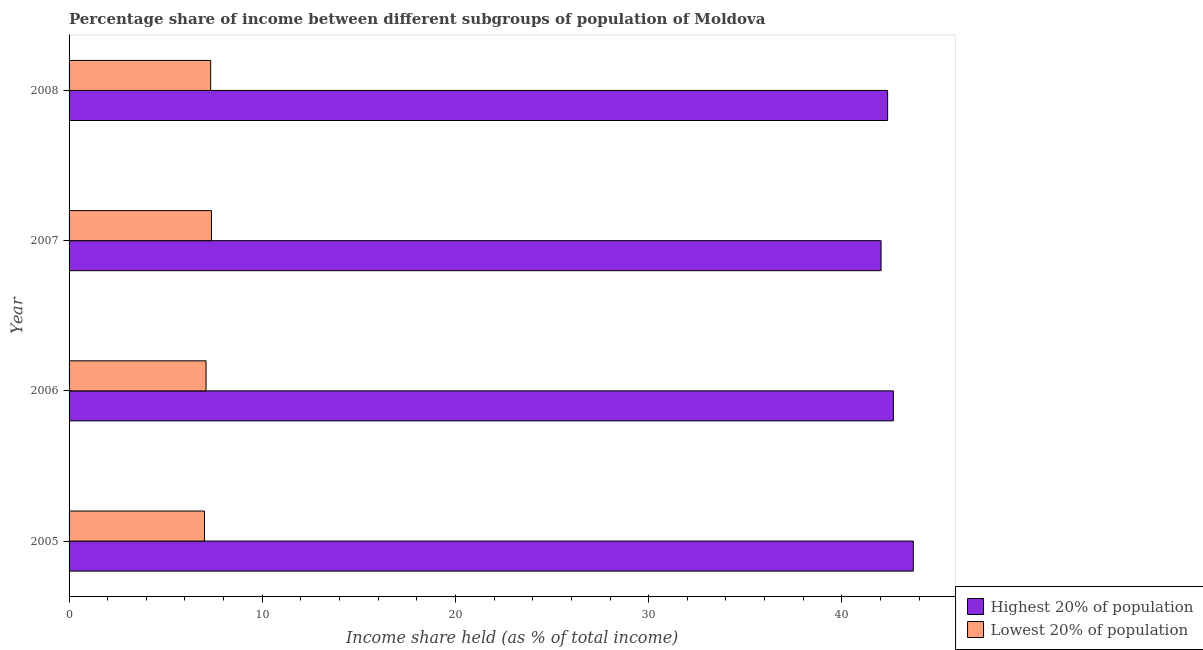How many different coloured bars are there?
Make the answer very short. 2. How many groups of bars are there?
Your response must be concise. 4. Are the number of bars per tick equal to the number of legend labels?
Keep it short and to the point. Yes. How many bars are there on the 1st tick from the bottom?
Offer a terse response. 2. What is the label of the 3rd group of bars from the top?
Your answer should be very brief. 2006. In how many cases, is the number of bars for a given year not equal to the number of legend labels?
Make the answer very short. 0. What is the income share held by lowest 20% of the population in 2006?
Your answer should be compact. 7.09. Across all years, what is the maximum income share held by lowest 20% of the population?
Your response must be concise. 7.37. Across all years, what is the minimum income share held by highest 20% of the population?
Keep it short and to the point. 42.03. In which year was the income share held by highest 20% of the population maximum?
Keep it short and to the point. 2005. What is the total income share held by lowest 20% of the population in the graph?
Your answer should be very brief. 28.8. What is the difference between the income share held by highest 20% of the population in 2007 and that in 2008?
Ensure brevity in your answer.  -0.34. What is the difference between the income share held by lowest 20% of the population in 2005 and the income share held by highest 20% of the population in 2008?
Offer a very short reply. -35.36. What is the average income share held by lowest 20% of the population per year?
Provide a short and direct response. 7.2. In the year 2006, what is the difference between the income share held by highest 20% of the population and income share held by lowest 20% of the population?
Give a very brief answer. 35.58. What is the ratio of the income share held by lowest 20% of the population in 2007 to that in 2008?
Make the answer very short. 1. Is the difference between the income share held by lowest 20% of the population in 2005 and 2006 greater than the difference between the income share held by highest 20% of the population in 2005 and 2006?
Keep it short and to the point. No. What is the difference between the highest and the lowest income share held by highest 20% of the population?
Provide a succinct answer. 1.67. In how many years, is the income share held by highest 20% of the population greater than the average income share held by highest 20% of the population taken over all years?
Offer a very short reply. 1. What does the 2nd bar from the top in 2006 represents?
Give a very brief answer. Highest 20% of population. What does the 2nd bar from the bottom in 2007 represents?
Offer a very short reply. Lowest 20% of population. Are all the bars in the graph horizontal?
Make the answer very short. Yes. Are the values on the major ticks of X-axis written in scientific E-notation?
Offer a very short reply. No. Does the graph contain grids?
Keep it short and to the point. No. How are the legend labels stacked?
Offer a very short reply. Vertical. What is the title of the graph?
Keep it short and to the point. Percentage share of income between different subgroups of population of Moldova. What is the label or title of the X-axis?
Provide a succinct answer. Income share held (as % of total income). What is the Income share held (as % of total income) of Highest 20% of population in 2005?
Your answer should be very brief. 43.7. What is the Income share held (as % of total income) of Lowest 20% of population in 2005?
Your answer should be very brief. 7.01. What is the Income share held (as % of total income) in Highest 20% of population in 2006?
Ensure brevity in your answer.  42.67. What is the Income share held (as % of total income) in Lowest 20% of population in 2006?
Your answer should be very brief. 7.09. What is the Income share held (as % of total income) of Highest 20% of population in 2007?
Your response must be concise. 42.03. What is the Income share held (as % of total income) of Lowest 20% of population in 2007?
Provide a short and direct response. 7.37. What is the Income share held (as % of total income) in Highest 20% of population in 2008?
Keep it short and to the point. 42.37. What is the Income share held (as % of total income) in Lowest 20% of population in 2008?
Ensure brevity in your answer.  7.33. Across all years, what is the maximum Income share held (as % of total income) of Highest 20% of population?
Give a very brief answer. 43.7. Across all years, what is the maximum Income share held (as % of total income) of Lowest 20% of population?
Keep it short and to the point. 7.37. Across all years, what is the minimum Income share held (as % of total income) of Highest 20% of population?
Make the answer very short. 42.03. Across all years, what is the minimum Income share held (as % of total income) in Lowest 20% of population?
Your answer should be compact. 7.01. What is the total Income share held (as % of total income) of Highest 20% of population in the graph?
Make the answer very short. 170.77. What is the total Income share held (as % of total income) of Lowest 20% of population in the graph?
Your response must be concise. 28.8. What is the difference between the Income share held (as % of total income) of Lowest 20% of population in 2005 and that in 2006?
Keep it short and to the point. -0.08. What is the difference between the Income share held (as % of total income) in Highest 20% of population in 2005 and that in 2007?
Keep it short and to the point. 1.67. What is the difference between the Income share held (as % of total income) of Lowest 20% of population in 2005 and that in 2007?
Your response must be concise. -0.36. What is the difference between the Income share held (as % of total income) of Highest 20% of population in 2005 and that in 2008?
Keep it short and to the point. 1.33. What is the difference between the Income share held (as % of total income) in Lowest 20% of population in 2005 and that in 2008?
Make the answer very short. -0.32. What is the difference between the Income share held (as % of total income) of Highest 20% of population in 2006 and that in 2007?
Offer a terse response. 0.64. What is the difference between the Income share held (as % of total income) in Lowest 20% of population in 2006 and that in 2007?
Your answer should be very brief. -0.28. What is the difference between the Income share held (as % of total income) of Lowest 20% of population in 2006 and that in 2008?
Your response must be concise. -0.24. What is the difference between the Income share held (as % of total income) in Highest 20% of population in 2007 and that in 2008?
Provide a short and direct response. -0.34. What is the difference between the Income share held (as % of total income) in Highest 20% of population in 2005 and the Income share held (as % of total income) in Lowest 20% of population in 2006?
Give a very brief answer. 36.61. What is the difference between the Income share held (as % of total income) in Highest 20% of population in 2005 and the Income share held (as % of total income) in Lowest 20% of population in 2007?
Offer a very short reply. 36.33. What is the difference between the Income share held (as % of total income) of Highest 20% of population in 2005 and the Income share held (as % of total income) of Lowest 20% of population in 2008?
Your response must be concise. 36.37. What is the difference between the Income share held (as % of total income) in Highest 20% of population in 2006 and the Income share held (as % of total income) in Lowest 20% of population in 2007?
Provide a short and direct response. 35.3. What is the difference between the Income share held (as % of total income) of Highest 20% of population in 2006 and the Income share held (as % of total income) of Lowest 20% of population in 2008?
Keep it short and to the point. 35.34. What is the difference between the Income share held (as % of total income) in Highest 20% of population in 2007 and the Income share held (as % of total income) in Lowest 20% of population in 2008?
Offer a very short reply. 34.7. What is the average Income share held (as % of total income) in Highest 20% of population per year?
Offer a very short reply. 42.69. In the year 2005, what is the difference between the Income share held (as % of total income) in Highest 20% of population and Income share held (as % of total income) in Lowest 20% of population?
Your answer should be compact. 36.69. In the year 2006, what is the difference between the Income share held (as % of total income) of Highest 20% of population and Income share held (as % of total income) of Lowest 20% of population?
Give a very brief answer. 35.58. In the year 2007, what is the difference between the Income share held (as % of total income) in Highest 20% of population and Income share held (as % of total income) in Lowest 20% of population?
Offer a terse response. 34.66. In the year 2008, what is the difference between the Income share held (as % of total income) of Highest 20% of population and Income share held (as % of total income) of Lowest 20% of population?
Your answer should be compact. 35.04. What is the ratio of the Income share held (as % of total income) in Highest 20% of population in 2005 to that in 2006?
Offer a terse response. 1.02. What is the ratio of the Income share held (as % of total income) in Lowest 20% of population in 2005 to that in 2006?
Your answer should be very brief. 0.99. What is the ratio of the Income share held (as % of total income) of Highest 20% of population in 2005 to that in 2007?
Ensure brevity in your answer.  1.04. What is the ratio of the Income share held (as % of total income) in Lowest 20% of population in 2005 to that in 2007?
Your answer should be compact. 0.95. What is the ratio of the Income share held (as % of total income) in Highest 20% of population in 2005 to that in 2008?
Offer a very short reply. 1.03. What is the ratio of the Income share held (as % of total income) in Lowest 20% of population in 2005 to that in 2008?
Make the answer very short. 0.96. What is the ratio of the Income share held (as % of total income) in Highest 20% of population in 2006 to that in 2007?
Your answer should be compact. 1.02. What is the ratio of the Income share held (as % of total income) of Lowest 20% of population in 2006 to that in 2007?
Keep it short and to the point. 0.96. What is the ratio of the Income share held (as % of total income) of Highest 20% of population in 2006 to that in 2008?
Give a very brief answer. 1.01. What is the ratio of the Income share held (as % of total income) in Lowest 20% of population in 2006 to that in 2008?
Offer a very short reply. 0.97. What is the ratio of the Income share held (as % of total income) in Highest 20% of population in 2007 to that in 2008?
Keep it short and to the point. 0.99. What is the difference between the highest and the second highest Income share held (as % of total income) of Lowest 20% of population?
Your answer should be very brief. 0.04. What is the difference between the highest and the lowest Income share held (as % of total income) in Highest 20% of population?
Give a very brief answer. 1.67. What is the difference between the highest and the lowest Income share held (as % of total income) of Lowest 20% of population?
Provide a short and direct response. 0.36. 